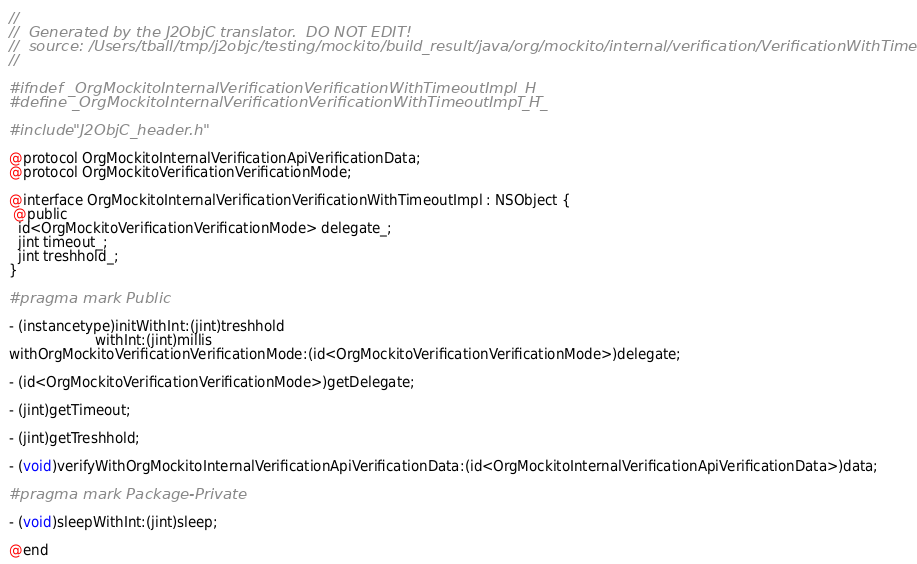Convert code to text. <code><loc_0><loc_0><loc_500><loc_500><_C_>//
//  Generated by the J2ObjC translator.  DO NOT EDIT!
//  source: /Users/tball/tmp/j2objc/testing/mockito/build_result/java/org/mockito/internal/verification/VerificationWithTimeoutImpl.java
//

#ifndef _OrgMockitoInternalVerificationVerificationWithTimeoutImpl_H_
#define _OrgMockitoInternalVerificationVerificationWithTimeoutImpl_H_

#include "J2ObjC_header.h"

@protocol OrgMockitoInternalVerificationApiVerificationData;
@protocol OrgMockitoVerificationVerificationMode;

@interface OrgMockitoInternalVerificationVerificationWithTimeoutImpl : NSObject {
 @public
  id<OrgMockitoVerificationVerificationMode> delegate_;
  jint timeout_;
  jint treshhold_;
}

#pragma mark Public

- (instancetype)initWithInt:(jint)treshhold
                    withInt:(jint)millis
withOrgMockitoVerificationVerificationMode:(id<OrgMockitoVerificationVerificationMode>)delegate;

- (id<OrgMockitoVerificationVerificationMode>)getDelegate;

- (jint)getTimeout;

- (jint)getTreshhold;

- (void)verifyWithOrgMockitoInternalVerificationApiVerificationData:(id<OrgMockitoInternalVerificationApiVerificationData>)data;

#pragma mark Package-Private

- (void)sleepWithInt:(jint)sleep;

@end
</code> 